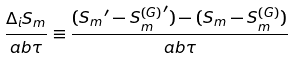<formula> <loc_0><loc_0><loc_500><loc_500>\frac { \Delta _ { i } S _ { m } } { a b \tau } \equiv \frac { ( { S _ { m } } ^ { \prime } - { S _ { m } ^ { ( G ) } } ^ { \prime } ) - ( S _ { m } - S _ { m } ^ { ( G ) } ) } { a b \tau }</formula> 